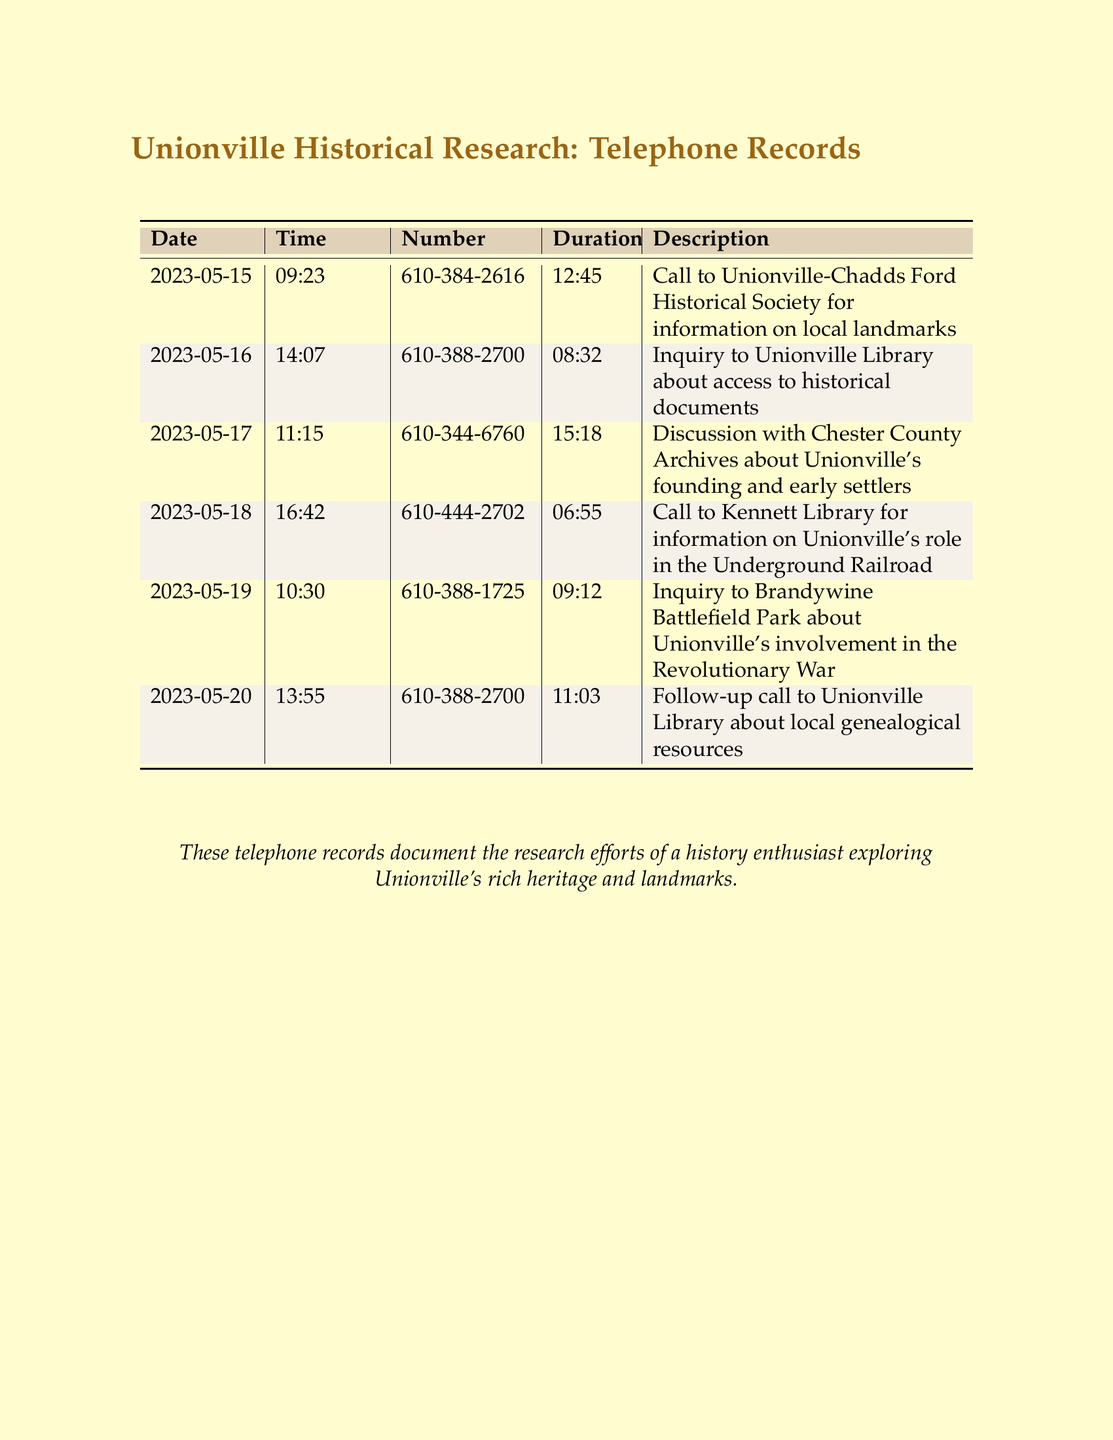what is the date of the first call? The first call in the record is dated May 15, 2023.
Answer: May 15, 2023 how long was the call with Chester County Archives? The duration of the call with Chester County Archives is specifically noted as 15 minutes and 18 seconds.
Answer: 15:18 which library was contacted for information on the Underground Railroad? The Kennett Library was contacted for information regarding Unionville's role in the Underground Railroad.
Answer: Kennett Library how many calls were made to the Unionville Library? There are two calls recorded to the Unionville Library in the document.
Answer: 2 what topic was discussed during the call on May 19? The inquiry made on May 19 concerned Unionville's involvement in the Revolutionary War.
Answer: Revolutionary War which organization was contacted for local genealogical resources? The follow-up call for local genealogical resources was made to the Unionville Library.
Answer: Unionville Library what was the time of the call regarding historical documents? The call regarding access to historical documents was made at 14:07.
Answer: 14:07 which historical society was called for information on local landmarks? The call for information on local landmarks was made to the Unionville-Chadds Ford Historical Society.
Answer: Unionville-Chadds Ford Historical Society how many different contacts are listed in the telephone records? There are five distinct contacts listed in the telephone records.
Answer: 5 